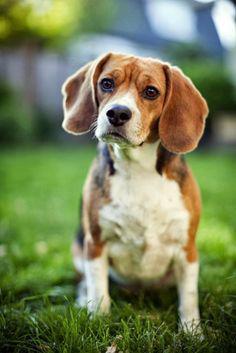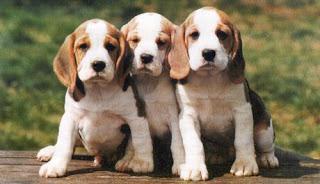The first image is the image on the left, the second image is the image on the right. Evaluate the accuracy of this statement regarding the images: "There are at least 5 puppies.". Is it true? Answer yes or no. No. 